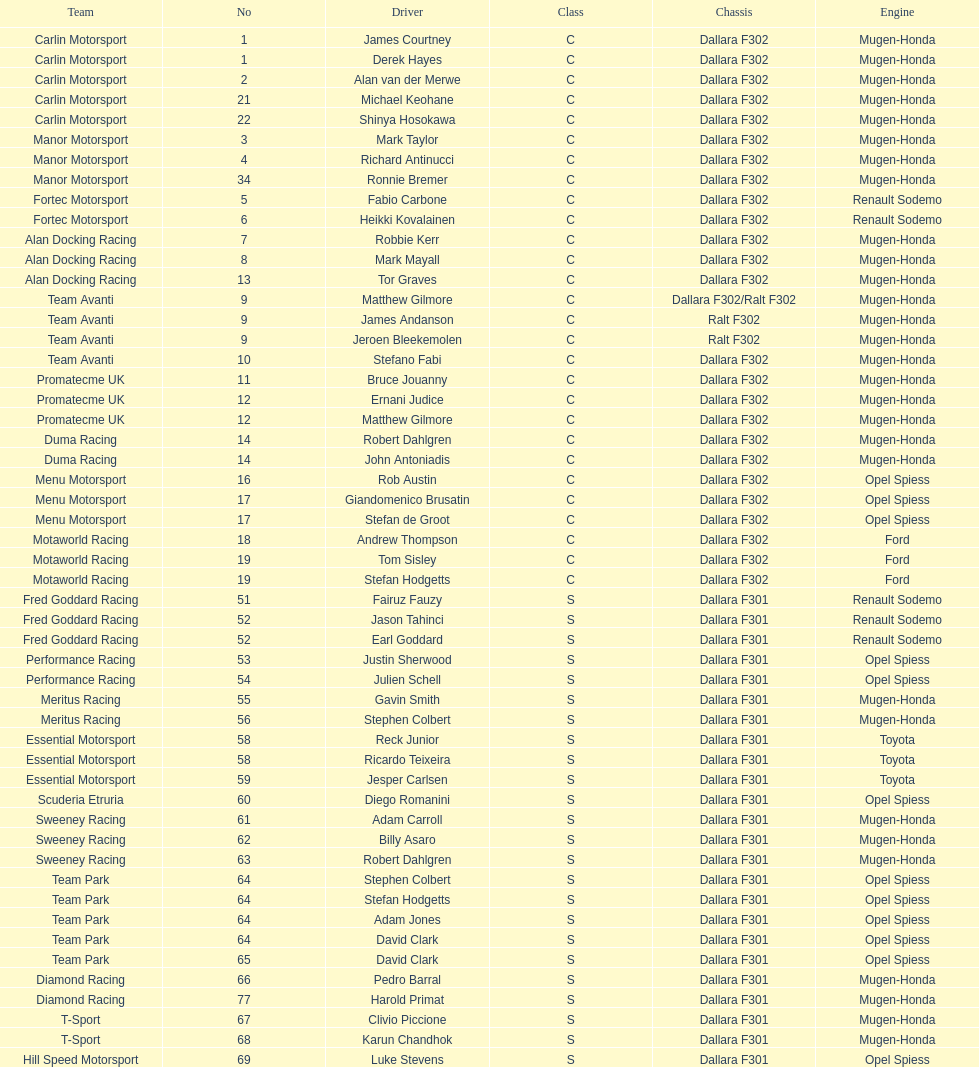What is the quantity of teams with drivers all originating from the same nation? 4. 